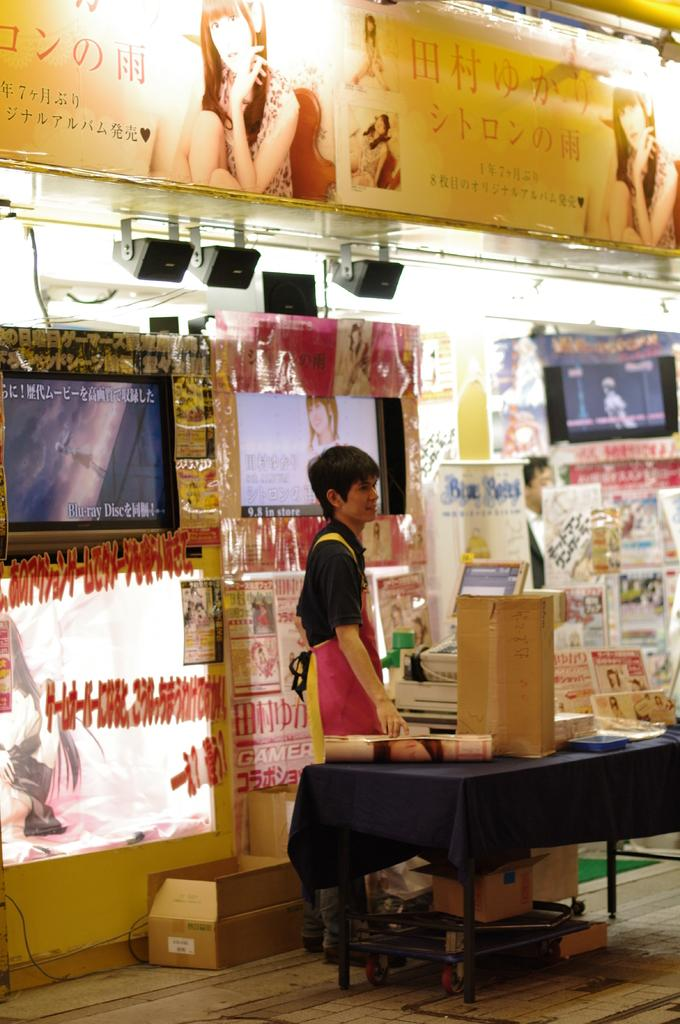Who or what is present in the image? There is a person in the image. What is the person wearing? The person is wearing a black shirt. What is the person's posture in the image? The person is standing. What is in front of the person? There is a table in front of the person. What can be found on the table? The table has objects on it. What can be seen in the background of the image? There are televisions in the background of the image. What type of brain is visible on the table in the image? There is no brain present on the table in the image; only objects are visible. What kind of apparel is the person wearing in the park? The image does not show the person in a park, and there is no mention of apparel other than the black shirt. 